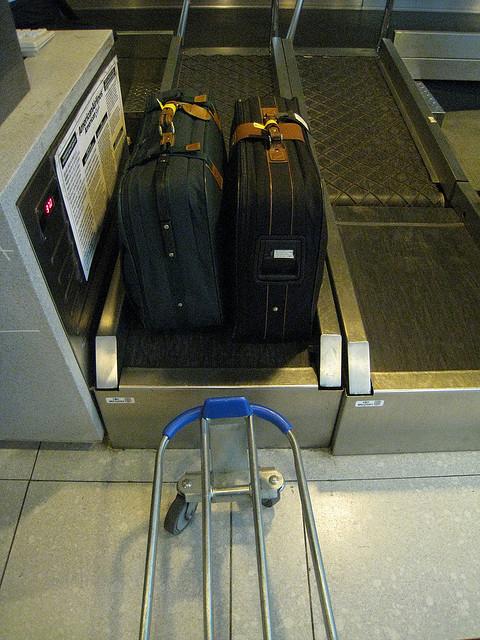Is there a trolley in this picture?
Be succinct. Yes. How many suitcases are being weighed?
Be succinct. 2. What color are the suitcases?
Short answer required. Black. 